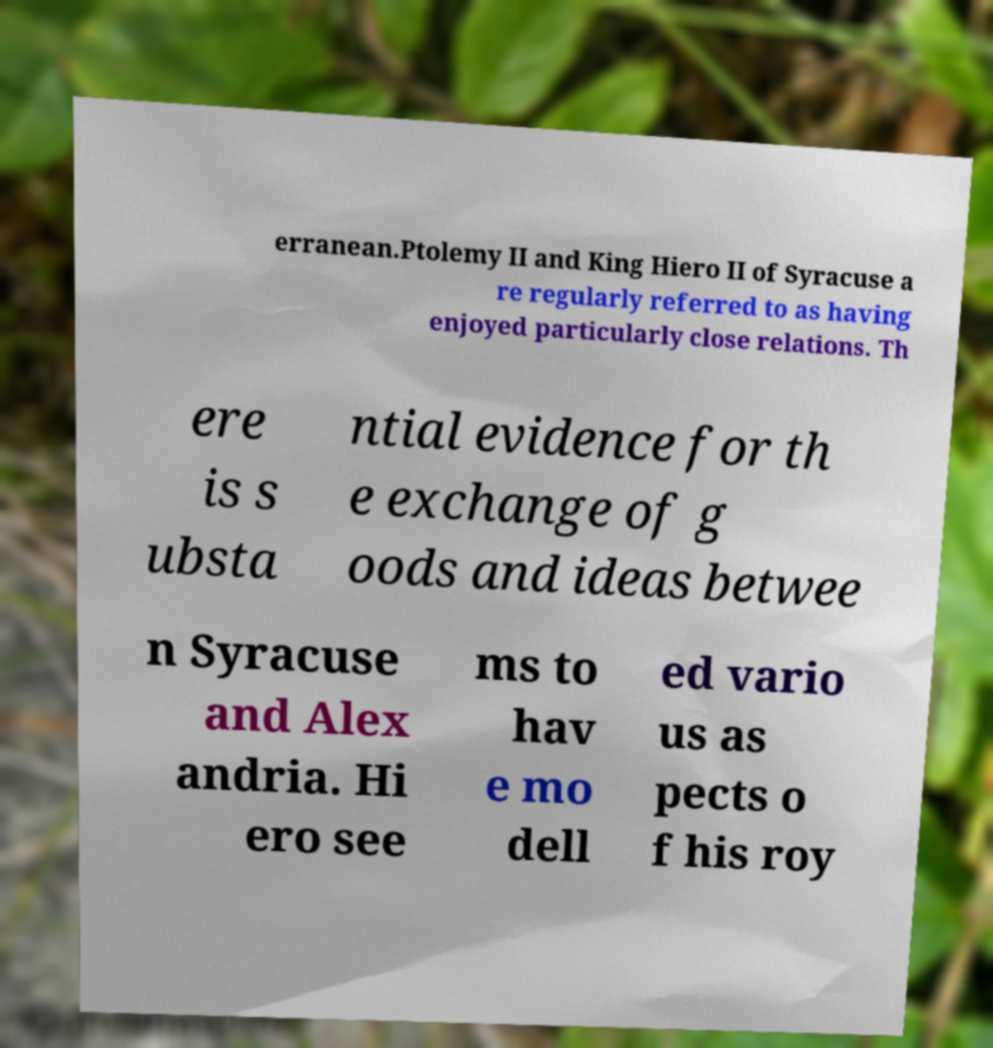I need the written content from this picture converted into text. Can you do that? erranean.Ptolemy II and King Hiero II of Syracuse a re regularly referred to as having enjoyed particularly close relations. Th ere is s ubsta ntial evidence for th e exchange of g oods and ideas betwee n Syracuse and Alex andria. Hi ero see ms to hav e mo dell ed vario us as pects o f his roy 